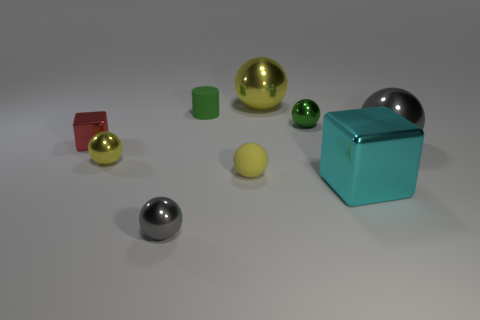Subtract all yellow cylinders. How many yellow spheres are left? 3 Subtract all gray balls. How many balls are left? 4 Subtract all green shiny balls. How many balls are left? 5 Subtract all cyan balls. Subtract all cyan blocks. How many balls are left? 6 Add 1 big cyan blocks. How many objects exist? 10 Subtract all cylinders. How many objects are left? 8 Add 1 brown matte cylinders. How many brown matte cylinders exist? 1 Subtract 0 blue cylinders. How many objects are left? 9 Subtract all tiny purple shiny objects. Subtract all gray spheres. How many objects are left? 7 Add 8 big cubes. How many big cubes are left? 9 